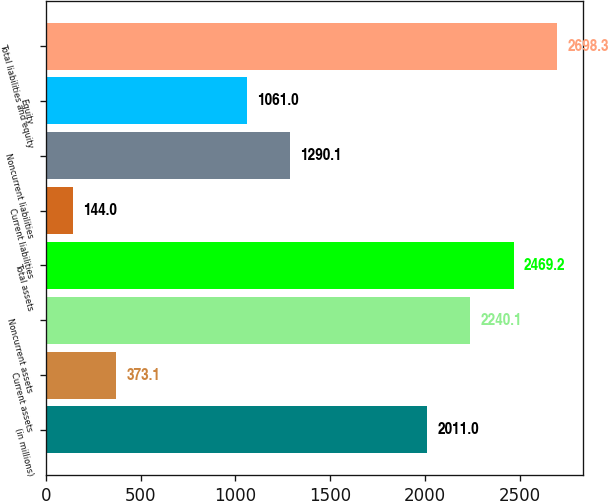<chart> <loc_0><loc_0><loc_500><loc_500><bar_chart><fcel>(in millions)<fcel>Current assets<fcel>Noncurrent assets<fcel>Total assets<fcel>Current liabilities<fcel>Noncurrent liabilities<fcel>Equity<fcel>Total liabilities and equity<nl><fcel>2011<fcel>373.1<fcel>2240.1<fcel>2469.2<fcel>144<fcel>1290.1<fcel>1061<fcel>2698.3<nl></chart> 